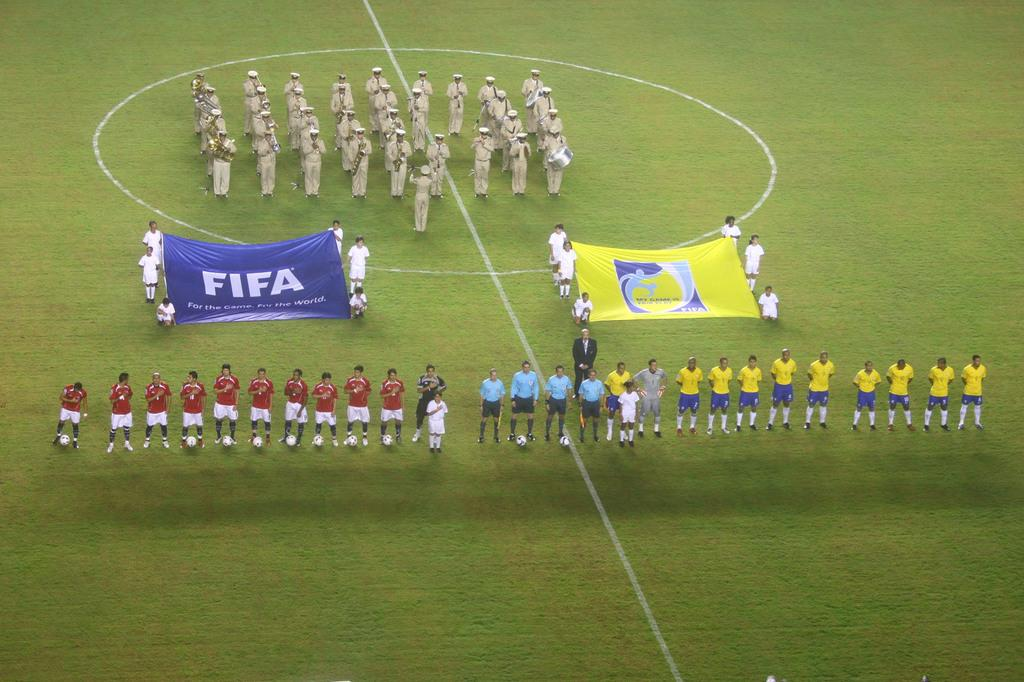Provide a one-sentence caption for the provided image. Soccer players hold up a banner that says FIFA. 